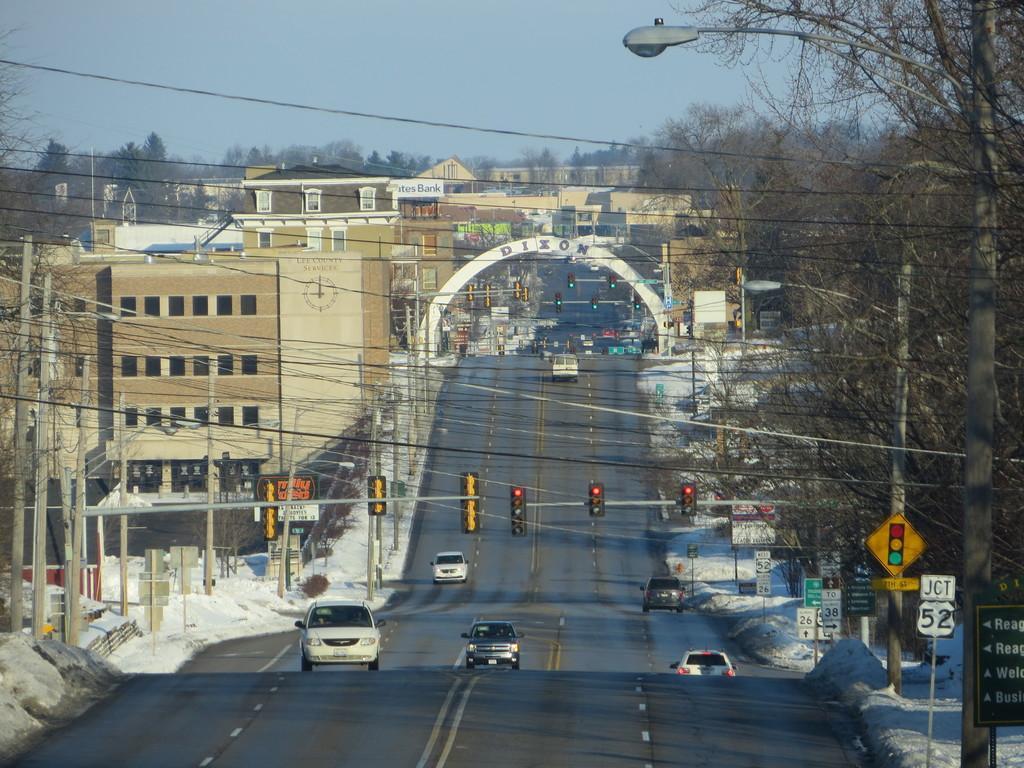Could you give a brief overview of what you see in this image? In this image we can see wires, poles, signboards, signal lights, trees, buildings and vehicles on the road. At the top of the image, we can see the sky and a light. 